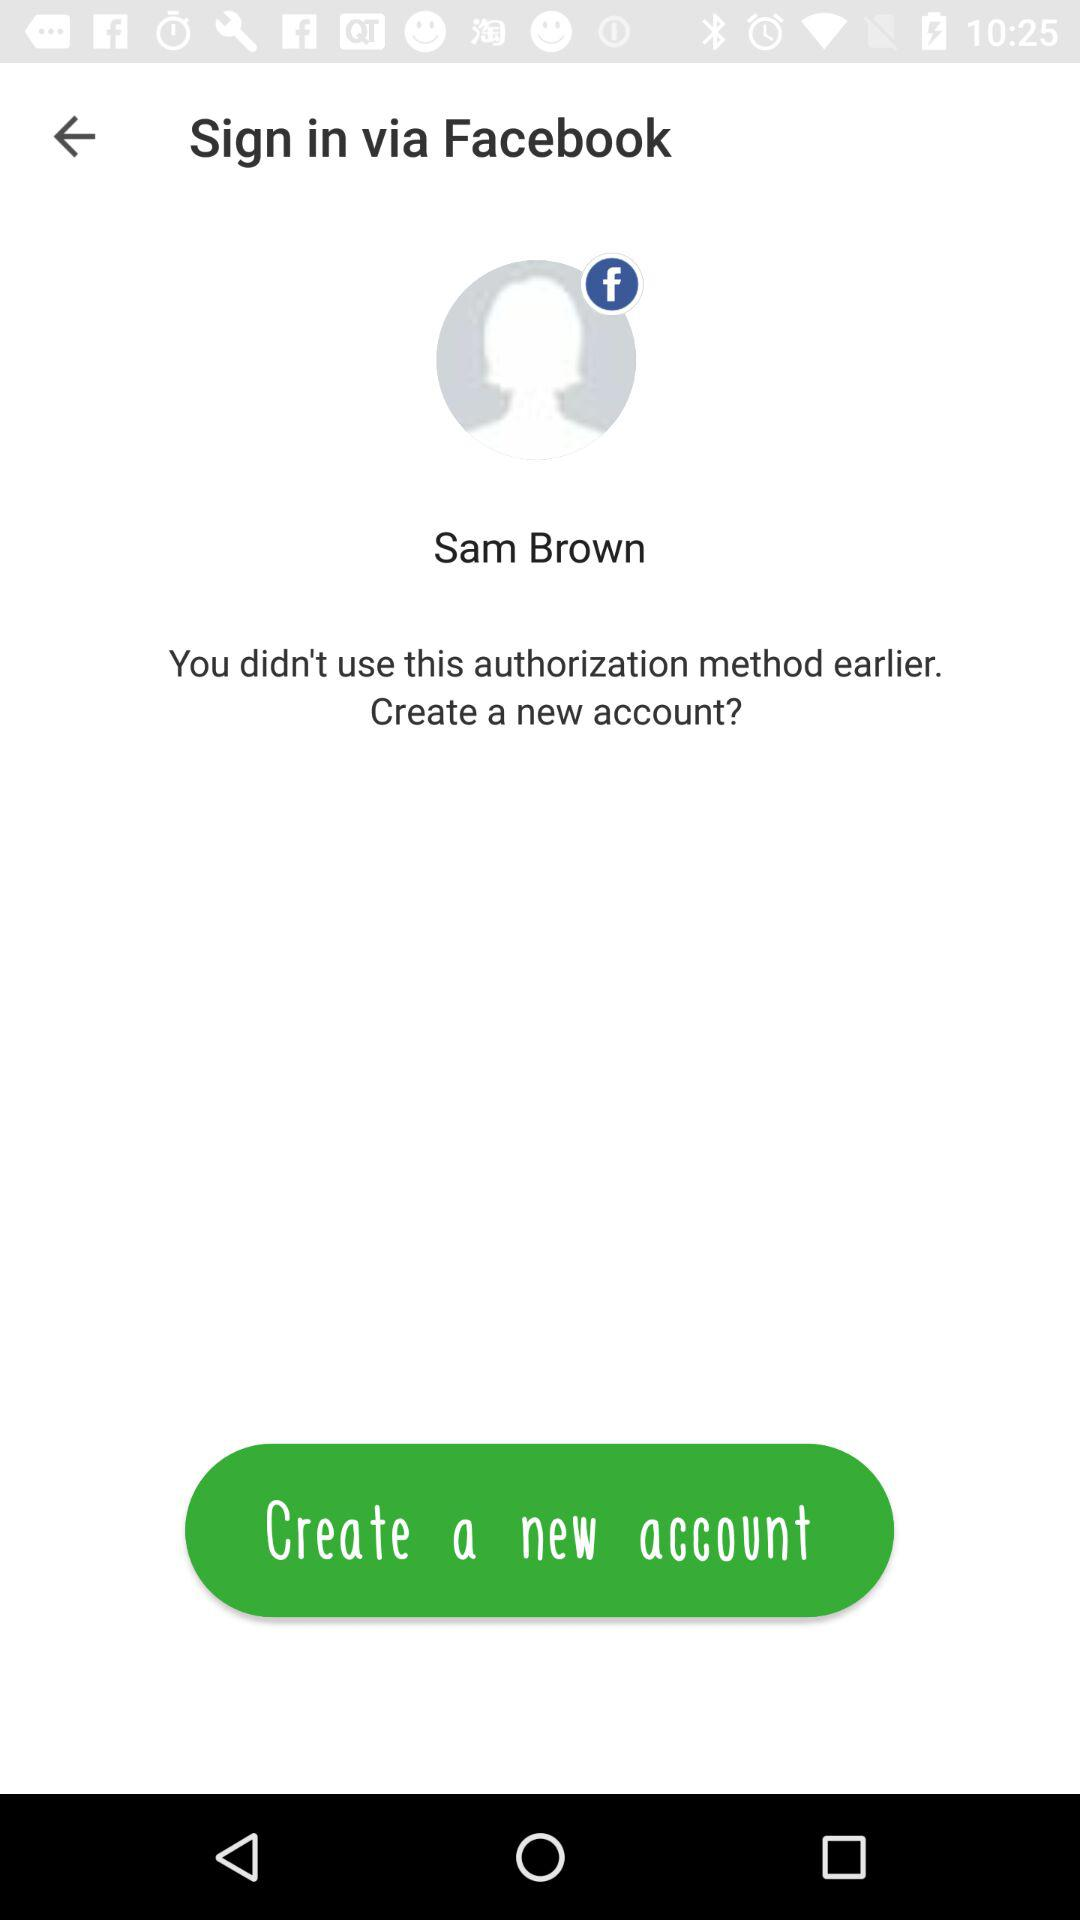Through what application can we sign in? You can sign in via "Facebook". 